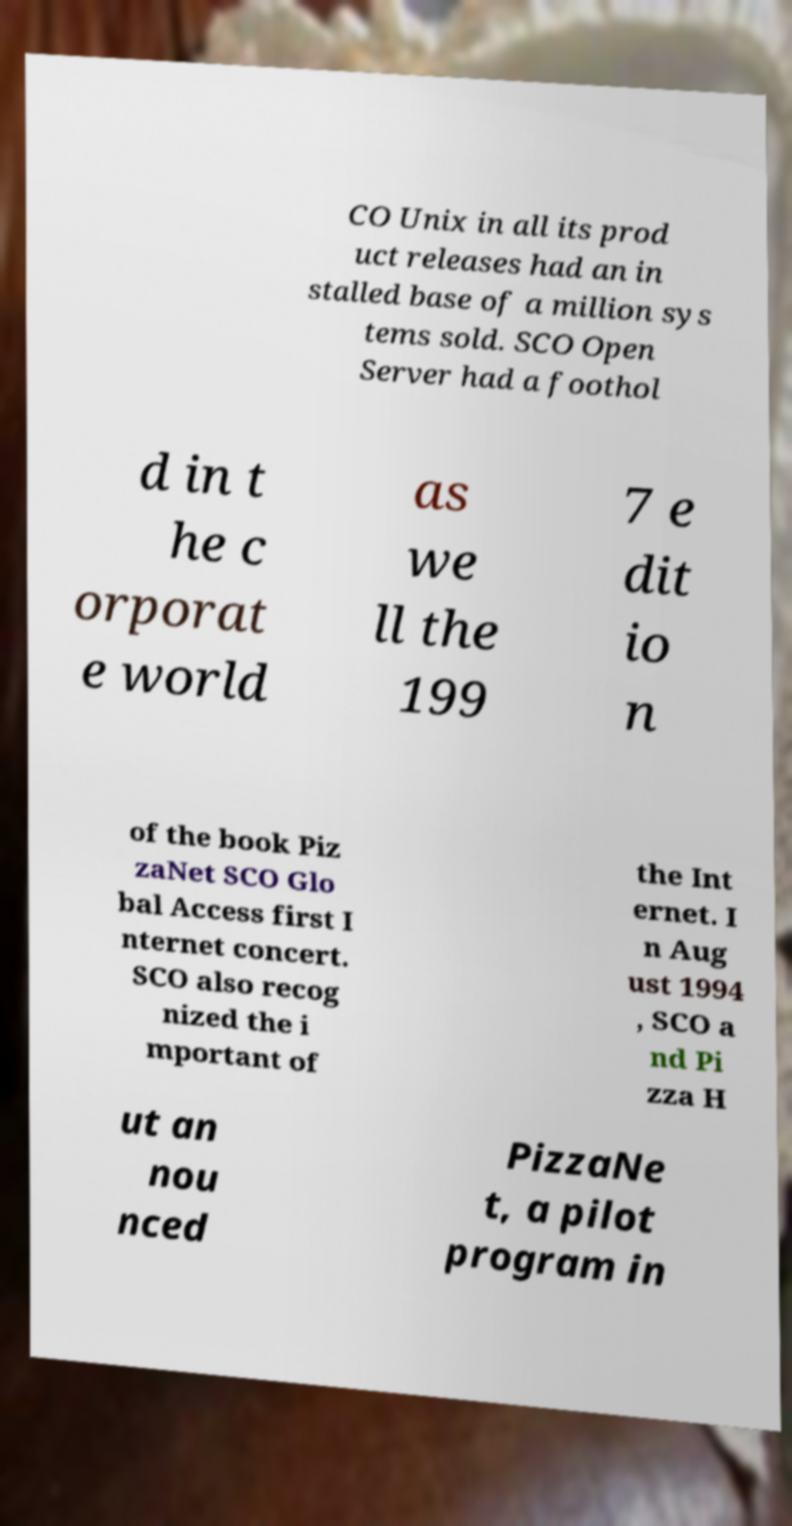Can you read and provide the text displayed in the image?This photo seems to have some interesting text. Can you extract and type it out for me? CO Unix in all its prod uct releases had an in stalled base of a million sys tems sold. SCO Open Server had a foothol d in t he c orporat e world as we ll the 199 7 e dit io n of the book Piz zaNet SCO Glo bal Access first I nternet concert. SCO also recog nized the i mportant of the Int ernet. I n Aug ust 1994 , SCO a nd Pi zza H ut an nou nced PizzaNe t, a pilot program in 